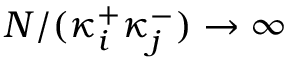Convert formula to latex. <formula><loc_0><loc_0><loc_500><loc_500>N / ( \kappa _ { i } ^ { + } \kappa _ { j } ^ { - } ) \to \infty</formula> 